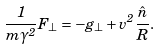Convert formula to latex. <formula><loc_0><loc_0><loc_500><loc_500>\frac { 1 } { m \gamma ^ { 2 } } { F } _ { \perp } = - { g } _ { \perp } + v ^ { 2 } \frac { { \hat { n } } } { R } .</formula> 